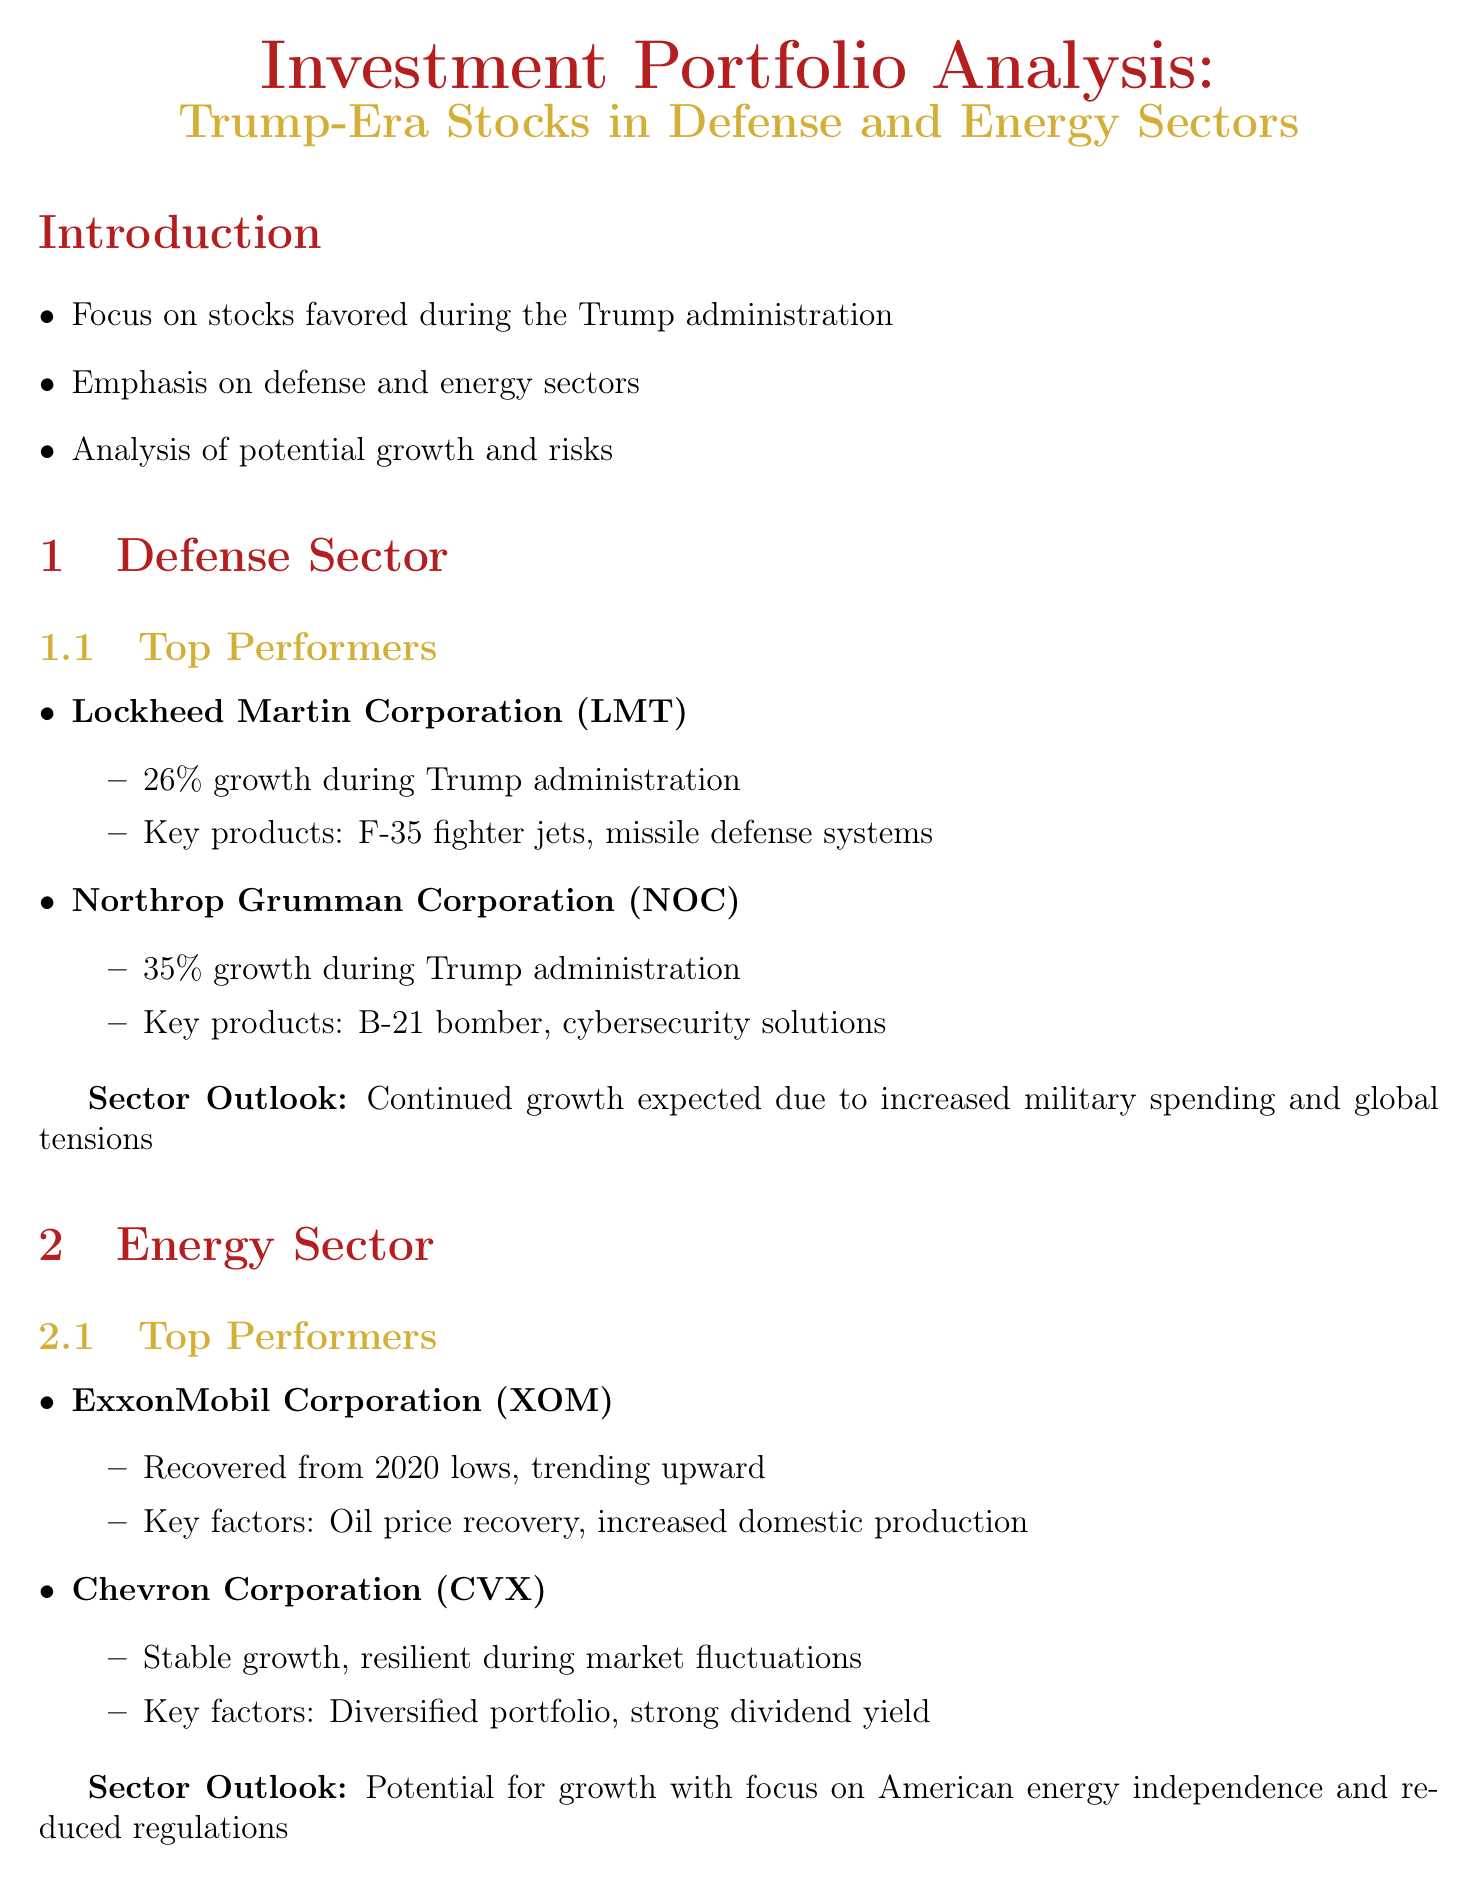What is the focus of the analysis? The document emphasizes stocks favored during the Trump administration, specifically in defense and energy sectors.
Answer: Stocks favored during the Trump administration What is the performance growth of Northrop Grumman Corporation? Northrop Grumman Corporation's performance during the Trump administration reflects a 35% growth.
Answer: 35% growth Which company is associated with the F-35 fighter jets? Lockheed Martin Corporation is known for its production of F-35 fighter jets.
Answer: Lockheed Martin Corporation What are the key products of ExxonMobil Corporation? ExxonMobil Corporation's performance is influenced by oil price recovery and increased domestic production.
Answer: Oil price recovery, increased domestic production What is the investment strategy recommendation regarding sector exposure? The report recommends maintaining a balanced portfolio with exposure to both defense and energy sectors.
Answer: Balanced portfolio with exposure to both sectors What is a potential risk mentioned in the document? One of the risks referenced is potential policy shifts under new administrations.
Answer: Potential policy shifts under new administrations What is the sector outlook for the defense sector? The outlook indicates continued growth expected due to increased military spending and global tensions.
Answer: Continued growth expected What investment vehicle is suggested for broader sector exposure? The document suggests considering ETFs like iShares U.S. Aerospace & Defense ETF for broader exposure.
Answer: iShares U.S. Aerospace & Defense ETF (ITA) 